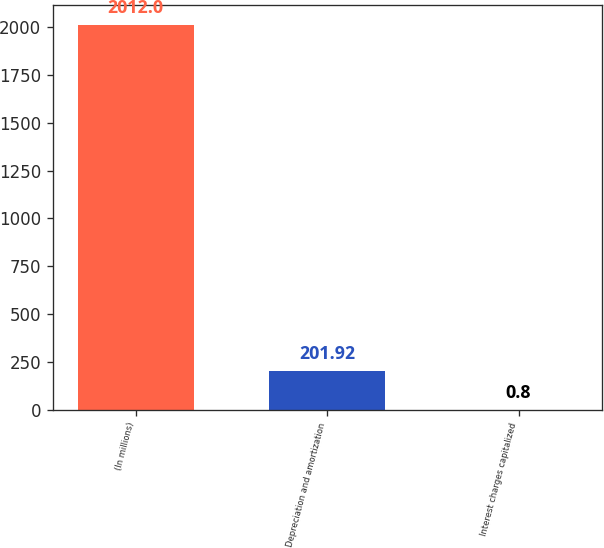<chart> <loc_0><loc_0><loc_500><loc_500><bar_chart><fcel>(In millions)<fcel>Depreciation and amortization<fcel>Interest charges capitalized<nl><fcel>2012<fcel>201.92<fcel>0.8<nl></chart> 